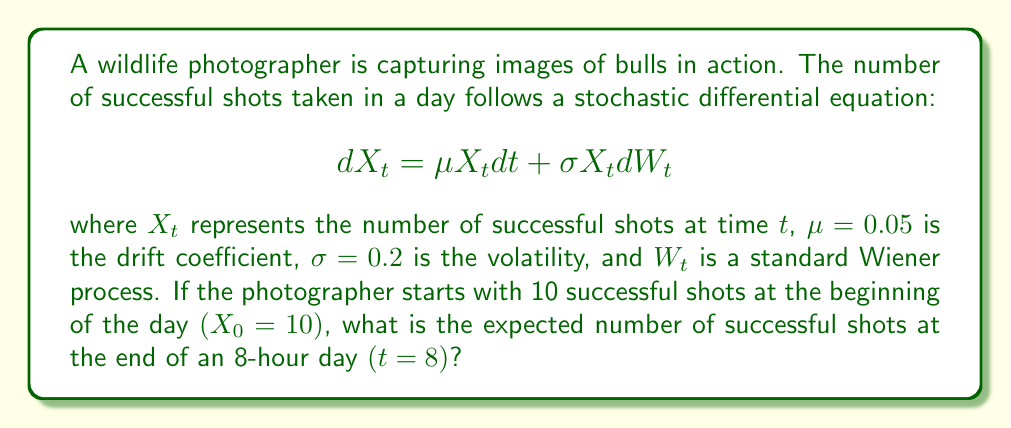Can you solve this math problem? To solve this problem, we need to use the properties of the geometric Brownian motion, which is described by the given stochastic differential equation.

1. The solution to this SDE is given by:

   $$X_t = X_0 \exp\left(\left(\mu - \frac{\sigma^2}{2}\right)t + \sigma W_t\right)$$

2. To find the expected value, we use the property that $E[e^{\sigma W_t}] = e^{\frac{\sigma^2 t}{2}}$. Therefore:

   $$E[X_t] = X_0 \exp\left(\mu t\right)$$

3. Substituting the given values:
   $X_0 = 10$
   $\mu = 0.05$
   $t = 8$

4. Calculate the expected number of successful shots:

   $$E[X_8] = 10 \exp(0.05 \cdot 8)$$
   $$E[X_8] = 10 \exp(0.4)$$
   $$E[X_8] = 10 \cdot 1.4918$$
   $$E[X_8] = 14.918$$

5. Round to two decimal places for a practical answer.
Answer: 14.92 shots 